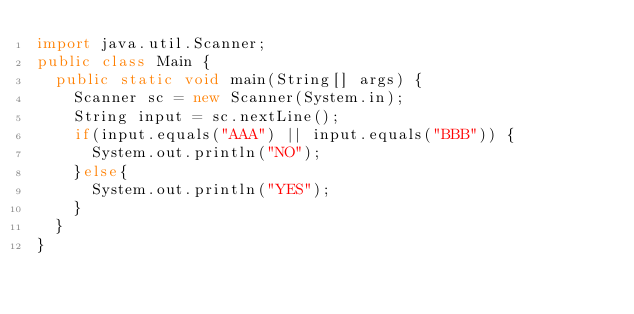Convert code to text. <code><loc_0><loc_0><loc_500><loc_500><_Java_>import java.util.Scanner;
public class Main {
  public static void main(String[] args) {
    Scanner sc = new Scanner(System.in);
    String input = sc.nextLine();
    if(input.equals("AAA") || input.equals("BBB")) {
      System.out.println("NO");
    }else{
      System.out.println("YES");
    }
  }
}</code> 